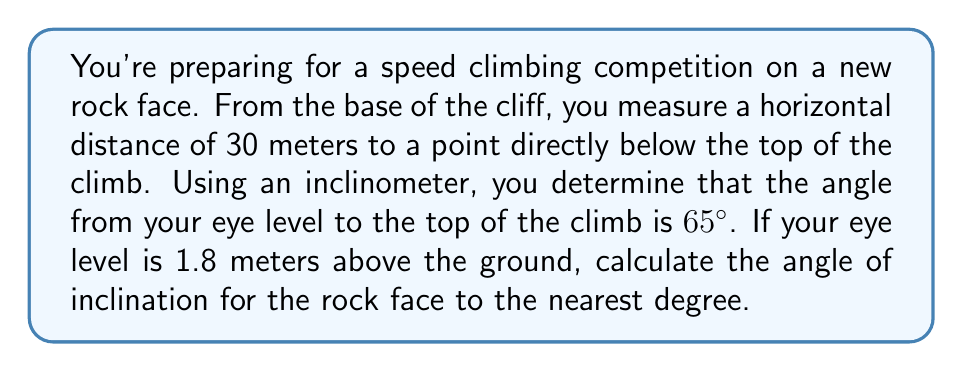Help me with this question. Let's approach this step-by-step:

1) First, let's visualize the problem:

[asy]
import geometry;

size(200);
pair A = (0,0), B = (30,0), C = (30,35), D = (0,1.8);
draw(A--B--C--A);
draw(D--C,dashed);
label("30m",B,S);
label("1.8m",A--D,W);
label("$65°$",D,NW);
label("$\theta$",A,NE);
label("A",A,SW);
label("B",B,SE);
label("C",C,NE);
label("D",D,NW);
[/asy]

2) We need to find the angle $\theta$ at point A.

3) We can use trigonometry to solve this. Let's consider the right triangle ABC:
   - The base of the triangle (AB) is 30 meters
   - We need to find the height (BC)

4) First, we need to account for the eye level height:
   $\tan 65° = \frac{BC - 1.8}{30}$

5) Rearranging this equation:
   $BC - 1.8 = 30 \tan 65°$
   $BC = 30 \tan 65° + 1.8$

6) Calculate:
   $BC = 30 \cdot 2.1445 + 1.8 = 66.135$ meters

7) Now we have a right triangle with:
   - Base (AB) = 30 meters
   - Height (BC) = 66.135 meters

8) We can find $\theta$ using the arctangent function:
   $\theta = \arctan(\frac{66.135}{30})$

9) Calculate:
   $\theta = \arctan(2.2045) \approx 65.6°$

10) Rounding to the nearest degree:
    $\theta \approx 66°$
Answer: $66°$ 